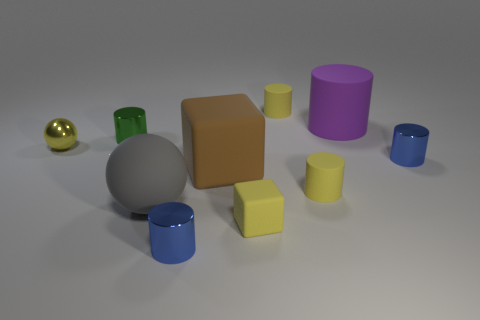Subtract 2 cylinders. How many cylinders are left? 4 Subtract all blue cylinders. How many cylinders are left? 4 Subtract all tiny blue cylinders. How many cylinders are left? 4 Subtract all cyan cylinders. Subtract all gray blocks. How many cylinders are left? 6 Subtract all balls. How many objects are left? 8 Add 5 small cubes. How many small cubes exist? 6 Subtract 0 purple cubes. How many objects are left? 10 Subtract all yellow objects. Subtract all small metallic cylinders. How many objects are left? 3 Add 1 gray balls. How many gray balls are left? 2 